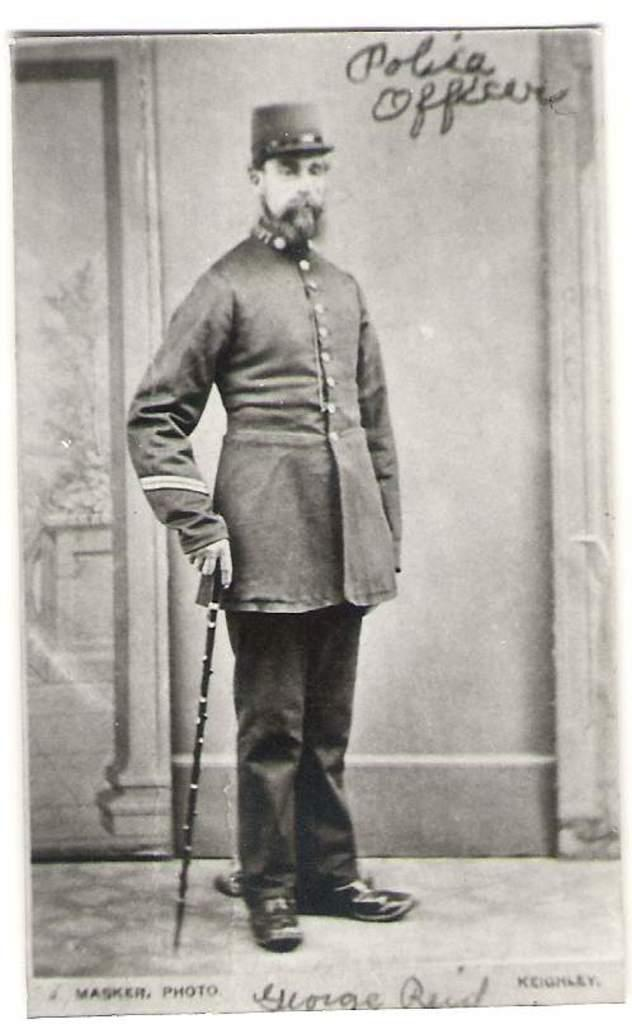<image>
Render a clear and concise summary of the photo. old black and white photo of man in uniform with polica officer written at top and name george reid at bottom 